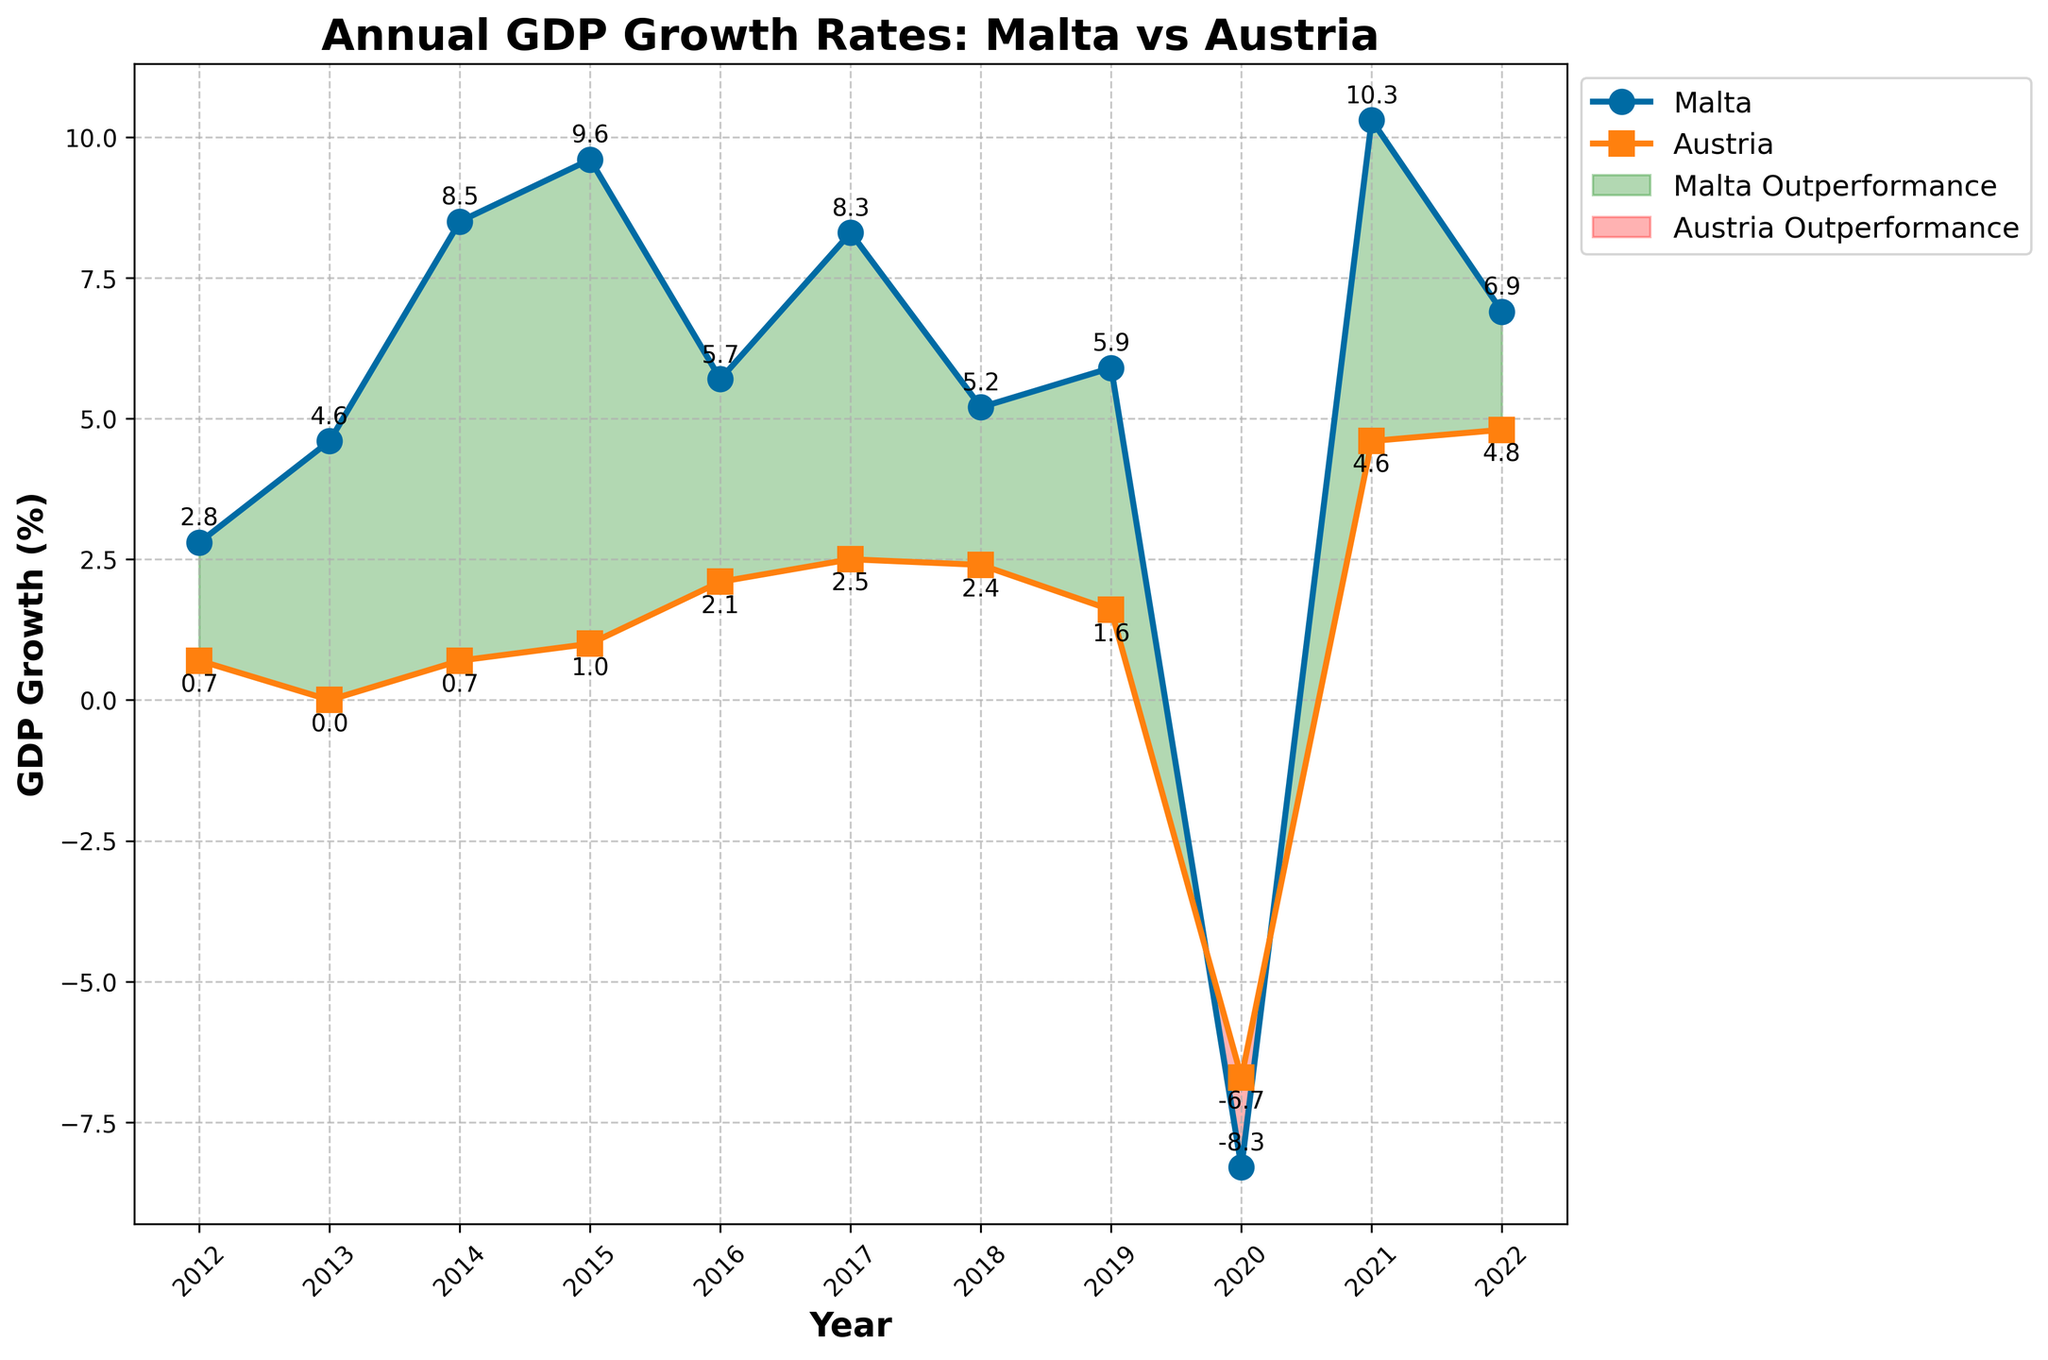What is the GDP growth rate in Malta in 2021? To find the GDP growth rate in Malta for 2021, locate the point on the Malta plot corresponding to the year 2021. The annotated value next to the point will provide the growth rate.
Answer: 10.3% In which year did Austria experience the lowest GDP growth rate? To determine the year with the lowest GDP growth rate for Austria, scan through the sequence of points on the Austria plot and locate the year annotated with the lowest value.
Answer: 2020 How does Malta's GDP growth rate in 2015 compare to Austria's for the same year? To compare the GDP growth rates in 2015, find the respective points for Malta and Austria corresponding to 2015 on the plot. Malta's growth rate is 9.6%, while Austria's is 1.0%.
Answer: Malta's is higher Which country experienced a more significant downturn in GDP in 2020, and by how much more? Identify the GDP growth rates for Malta and Austria in 2020. Malta's growth rate is -8.3%, while Austria's is -6.7%. The difference is 8.3 - 6.7, resulting in a 1.6 percentage point higher downturn for Malta.
Answer: Malta by 1.6% What is the overall trend in Malta's GDP growth rate from 2012 to 2022? Observe the progression of data points for Malta from 2012 to 2022. The trend shows an overall increase in GDP growth rates with fluctuations, significant downturn in 2020, and a recovery afterward.
Answer: Increasing with fluctuations In how many years did Malta's GDP growth rate outperform Austria's? Identify the years where Malta's data points are higher than Austria's on the plot. These occur in 2012, 2013, 2014, 2015, 2016, 2017, 2018, 2019, 2021, and 2022. Count these years.
Answer: 10 years What is the average annual GDP growth rate for Malta over this last decade? Sum Malta’s GDP growth rates from 2012 to 2022 (2.8 + 4.6 + 8.5 + 9.6 + 5.7 + 8.3 + 5.2 + 5.9 - 8.3 + 10.3 + 6.9) and divide by the number of years (11). The sum is 59.5, and the average is 59.5/11.
Answer: 5.41% How many years did Austria's GDP growth rate exceed 2%? Look at the Austria plot and identify years where the annotated values exceed 2%. These are 2016, 2017, 2021, and 2022. Count these years.
Answer: 4 years During what years did Austria outperform Malta in GDP growth rate, and what are the visual indicators? Austria outperformed Malta in GDP growth rate in 2020. This is visually indicated by the area filled in red between the Malta and Austria GDP growth lines.
Answer: 2020 